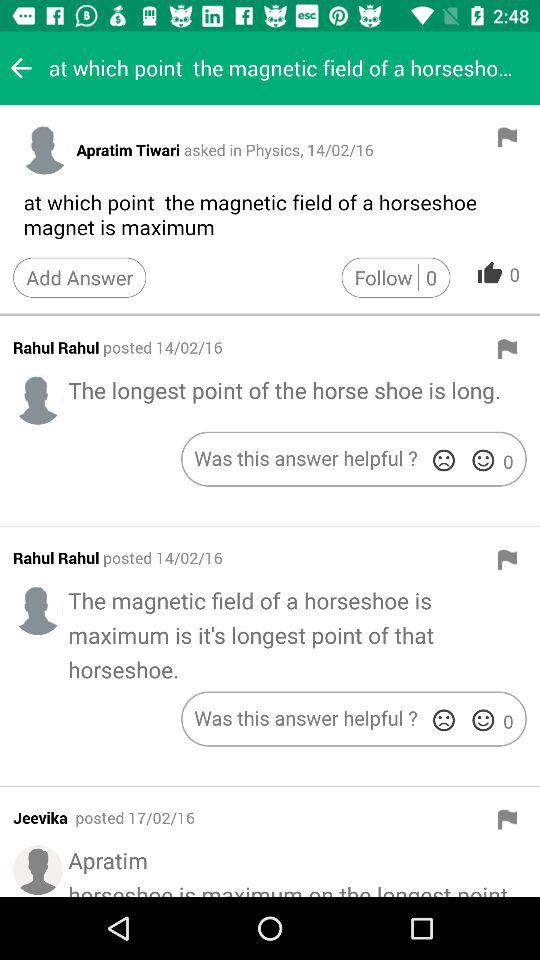On what date did Rahul Rahul post his comments? Rahul Rahul posted his comments on February 14, 2016. 